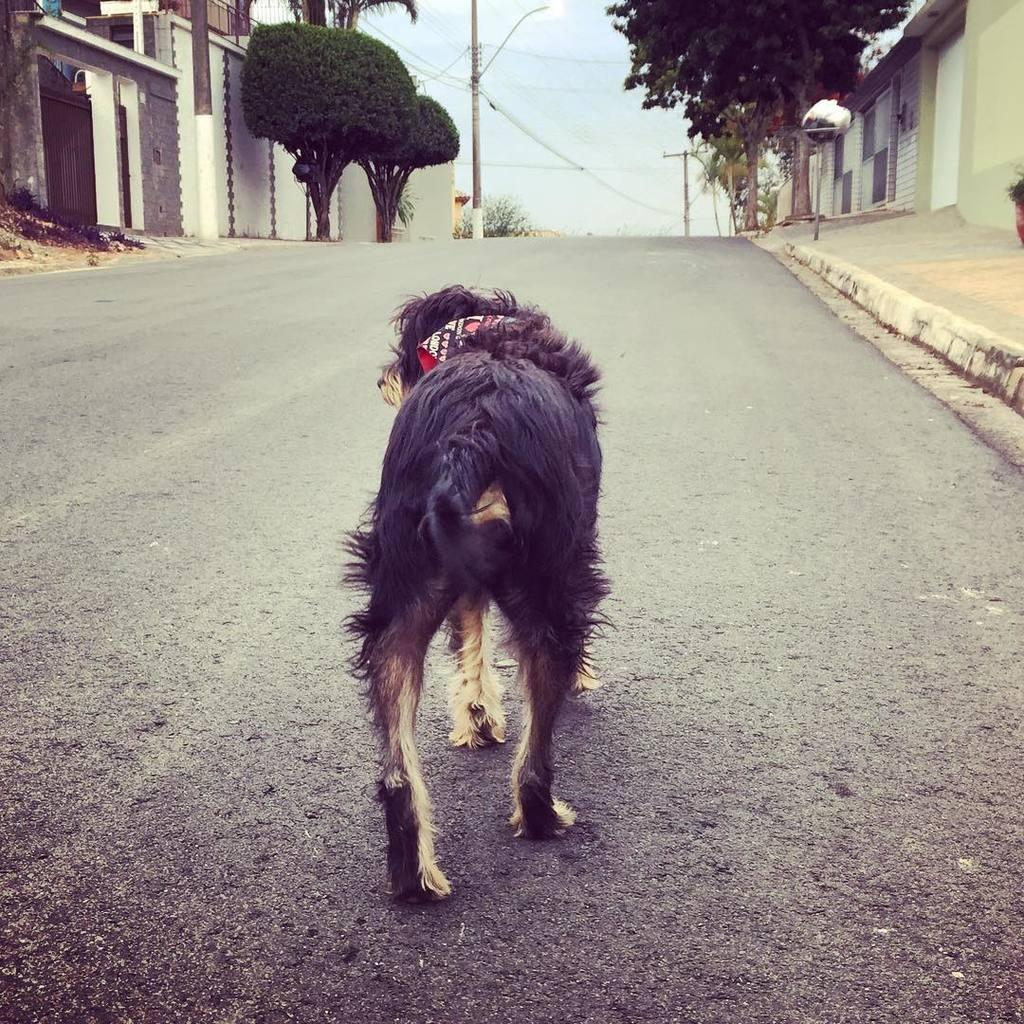What is the main subject in the center of the image? There is a dog in the center of the image. Where is the dog located? The dog is on the road. What can be seen in the background of the image? There is sky, buildings, trees, and poles visible in the background of the image. What type of insurance policy do the dog's brothers have in the image? There is no mention of insurance or brothers in the image, as it features a dog on the road with a background of sky, buildings, trees, and poles. 